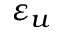<formula> <loc_0><loc_0><loc_500><loc_500>\varepsilon _ { u }</formula> 